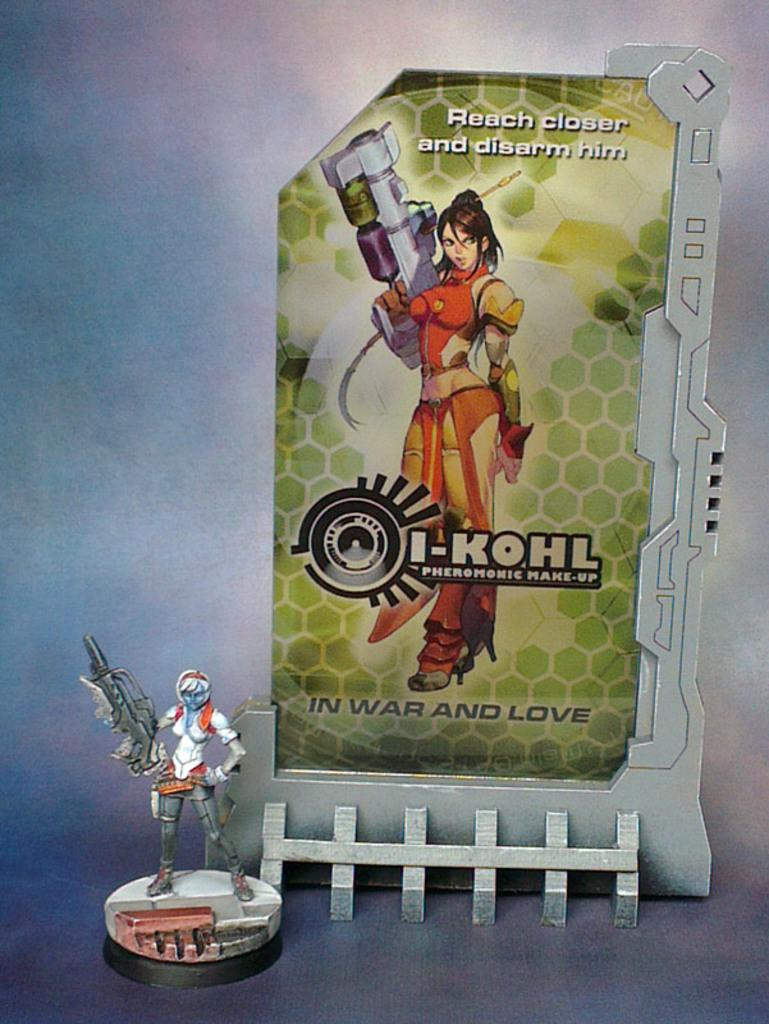<image>
Render a clear and concise summary of the photo. a small toy in front of a poster that says 'reach closer and disarm him' 